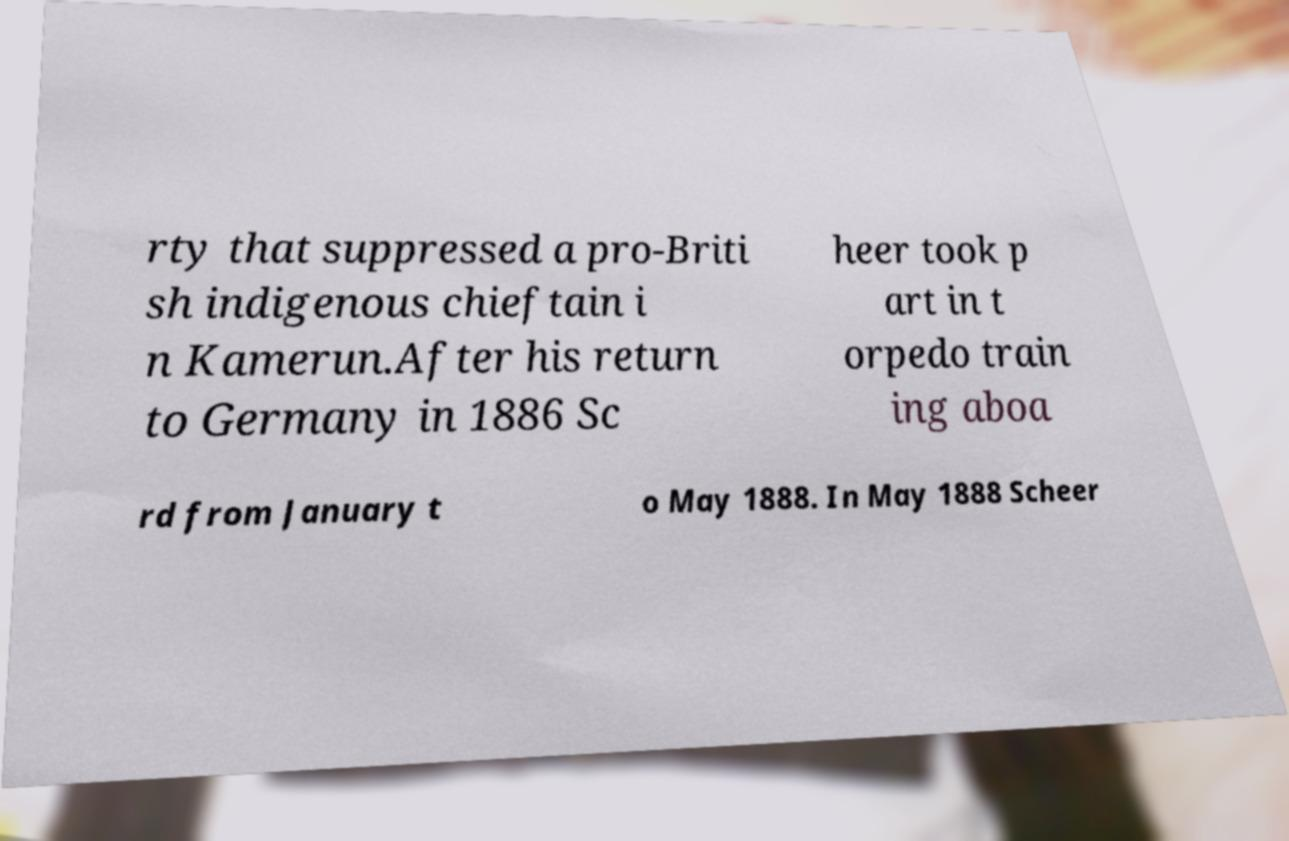I need the written content from this picture converted into text. Can you do that? rty that suppressed a pro-Briti sh indigenous chieftain i n Kamerun.After his return to Germany in 1886 Sc heer took p art in t orpedo train ing aboa rd from January t o May 1888. In May 1888 Scheer 